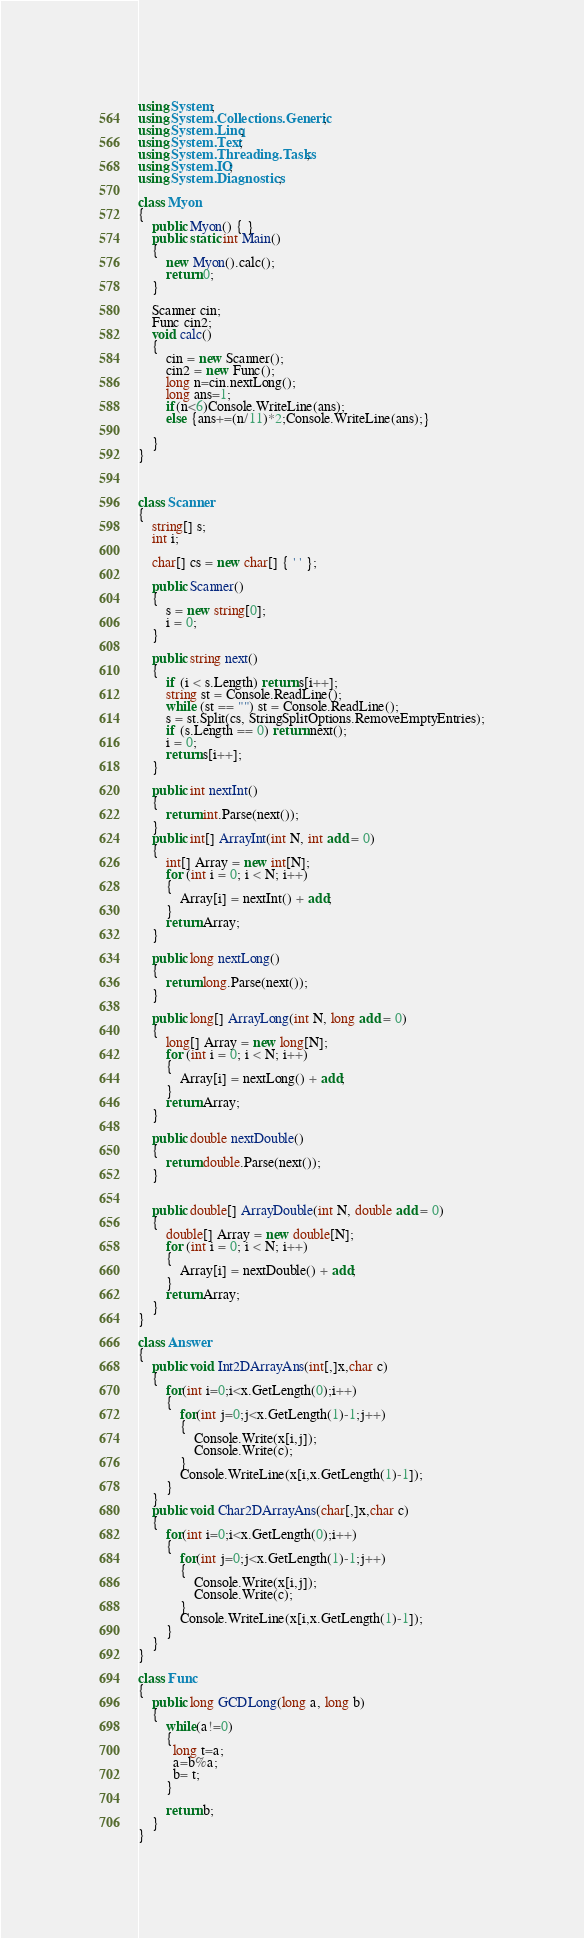<code> <loc_0><loc_0><loc_500><loc_500><_C#_>using System;
using System.Collections.Generic;
using System.Linq;
using System.Text;
using System.Threading.Tasks;
using System.IO;
using System.Diagnostics;

class Myon
{
    public Myon() { }
    public static int Main()
    {
        new Myon().calc();
        return 0;
    }

    Scanner cin;
    Func cin2;
    void calc()
    {
        cin = new Scanner();
        cin2 = new Func();
        long n=cin.nextLong();
        long ans=1;
        if(n<6)Console.WriteLine(ans);
        else {ans+=(n/11)*2;Console.WriteLine(ans);}
        
    }
}



class Scanner
{
    string[] s;
    int i;

    char[] cs = new char[] { ' ' };

    public Scanner()
    {
        s = new string[0];
        i = 0;
    }

    public string next()
    {
        if (i < s.Length) return s[i++];
        string st = Console.ReadLine();
        while (st == "") st = Console.ReadLine();
        s = st.Split(cs, StringSplitOptions.RemoveEmptyEntries);
        if (s.Length == 0) return next();
        i = 0;
        return s[i++];
    }

    public int nextInt()
    {
        return int.Parse(next());
    }
    public int[] ArrayInt(int N, int add = 0)
    {
        int[] Array = new int[N];
        for (int i = 0; i < N; i++)
        {
            Array[i] = nextInt() + add;
        }
        return Array;
    }

    public long nextLong()
    {
        return long.Parse(next());
    }

    public long[] ArrayLong(int N, long add = 0)
    {
        long[] Array = new long[N];
        for (int i = 0; i < N; i++)
        {
            Array[i] = nextLong() + add;
        }
        return Array;
    }

    public double nextDouble()
    {
        return double.Parse(next());
    }


    public double[] ArrayDouble(int N, double add = 0)
    {
        double[] Array = new double[N];
        for (int i = 0; i < N; i++)
        {
            Array[i] = nextDouble() + add;
        }
        return Array;
    }
}

class Answer
{
    public void Int2DArrayAns(int[,]x,char c)
    {
        for(int i=0;i<x.GetLength(0);i++)
        {
            for(int j=0;j<x.GetLength(1)-1;j++)
            {
                Console.Write(x[i,j]);
                Console.Write(c);
            }
            Console.WriteLine(x[i,x.GetLength(1)-1]);
        }
    }
    public void Char2DArrayAns(char[,]x,char c)
    {
        for(int i=0;i<x.GetLength(0);i++)
        {
            for(int j=0;j<x.GetLength(1)-1;j++)
            {
                Console.Write(x[i,j]);
                Console.Write(c);
            }
            Console.WriteLine(x[i,x.GetLength(1)-1]);
        }
    }
}

class Func
{
    public long GCDLong(long a, long b)
    {
        while(a!=0)
        {
          long t=a;
          a=b%a;
          b= t;
        }
      
        return b;        
    }
}
</code> 